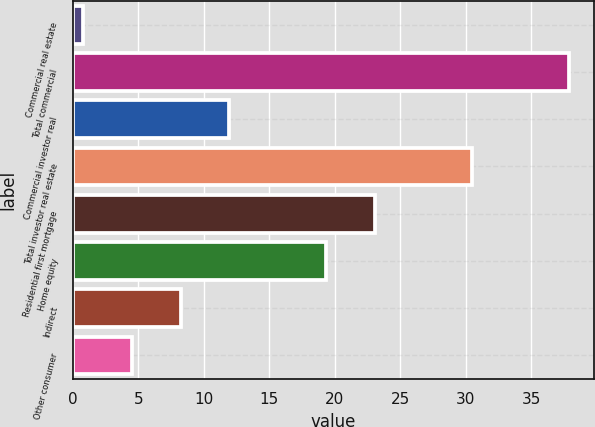Convert chart to OTSL. <chart><loc_0><loc_0><loc_500><loc_500><bar_chart><fcel>Commercial real estate<fcel>Total commercial<fcel>Commercial investor real<fcel>Total investor real estate<fcel>Residential first mortgage<fcel>Home equity<fcel>Indirect<fcel>Other consumer<nl><fcel>0.8<fcel>37.9<fcel>11.93<fcel>30.48<fcel>23.06<fcel>19.35<fcel>8.22<fcel>4.51<nl></chart> 